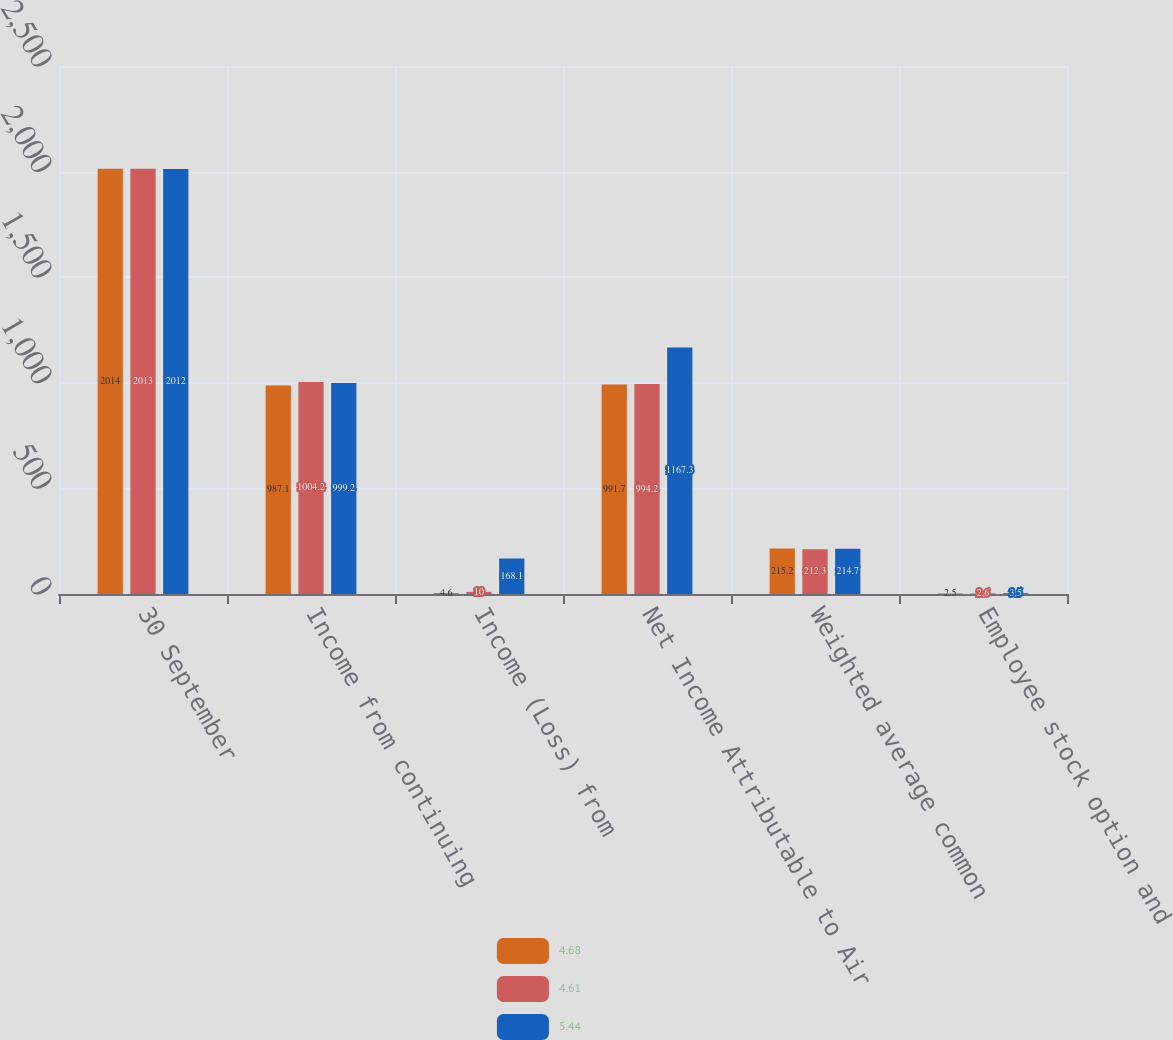<chart> <loc_0><loc_0><loc_500><loc_500><stacked_bar_chart><ecel><fcel>30 September<fcel>Income from continuing<fcel>Income (Loss) from<fcel>Net Income Attributable to Air<fcel>Weighted average common<fcel>Employee stock option and<nl><fcel>4.68<fcel>2014<fcel>987.1<fcel>4.6<fcel>991.7<fcel>215.2<fcel>2.5<nl><fcel>4.61<fcel>2013<fcel>1004.2<fcel>10<fcel>994.2<fcel>212.3<fcel>2.6<nl><fcel>5.44<fcel>2012<fcel>999.2<fcel>168.1<fcel>1167.3<fcel>214.7<fcel>3.5<nl></chart> 